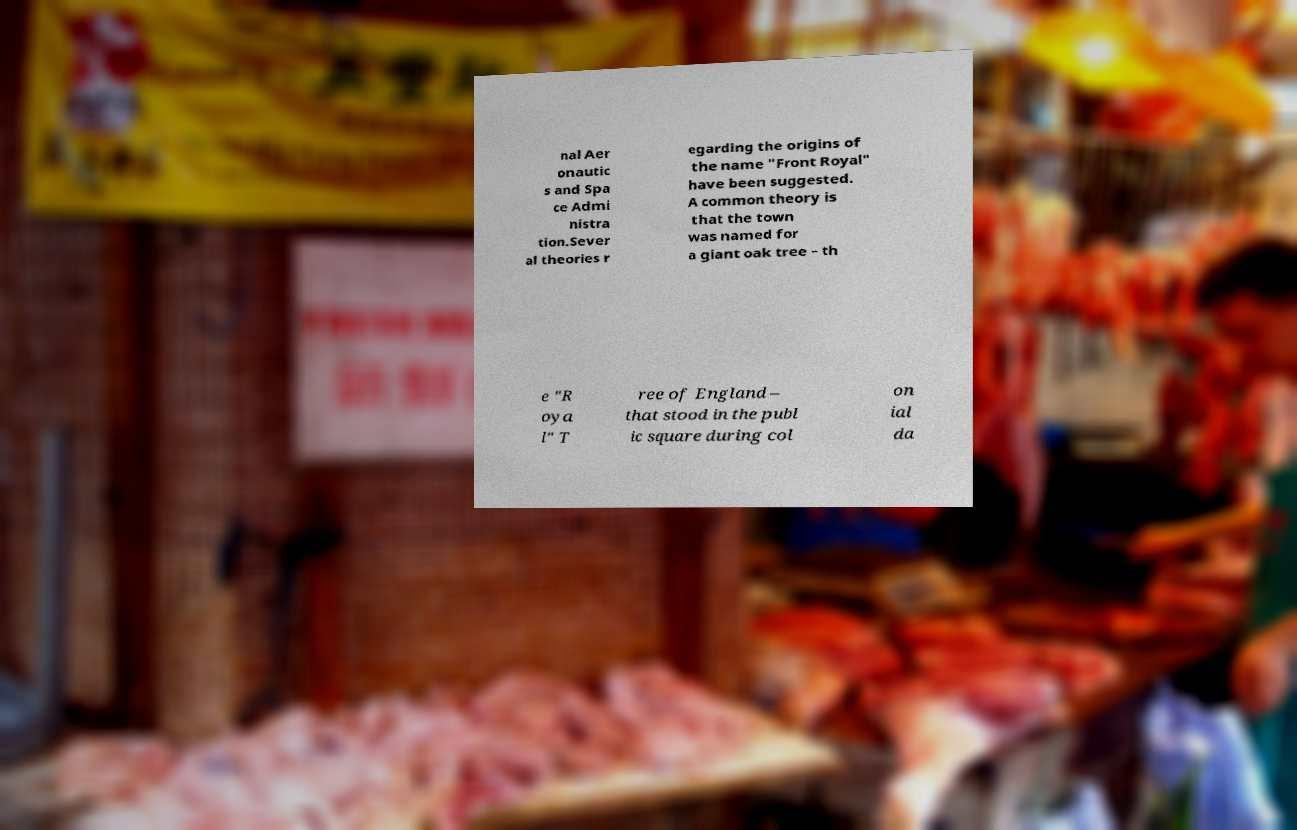Could you extract and type out the text from this image? nal Aer onautic s and Spa ce Admi nistra tion.Sever al theories r egarding the origins of the name "Front Royal" have been suggested. A common theory is that the town was named for a giant oak tree – th e "R oya l" T ree of England – that stood in the publ ic square during col on ial da 